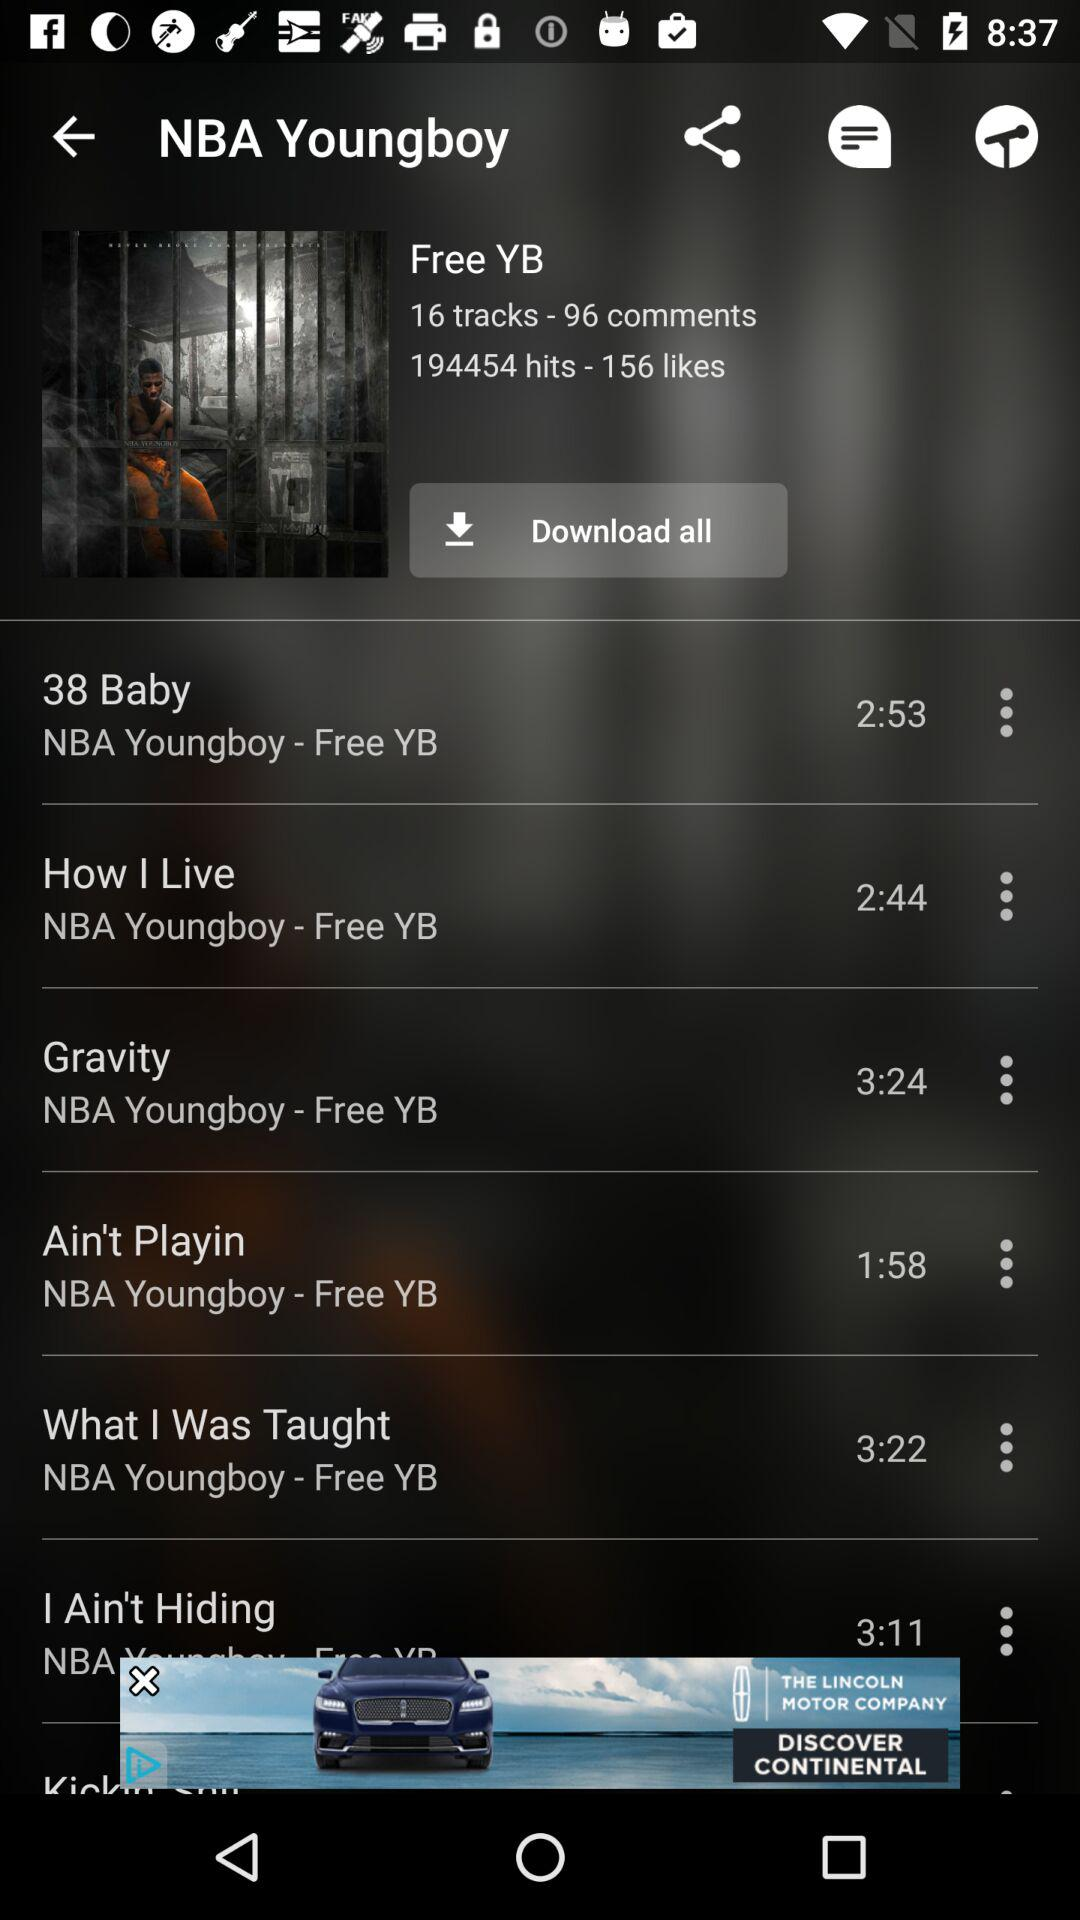How many comments are there? There are 96 comments. 